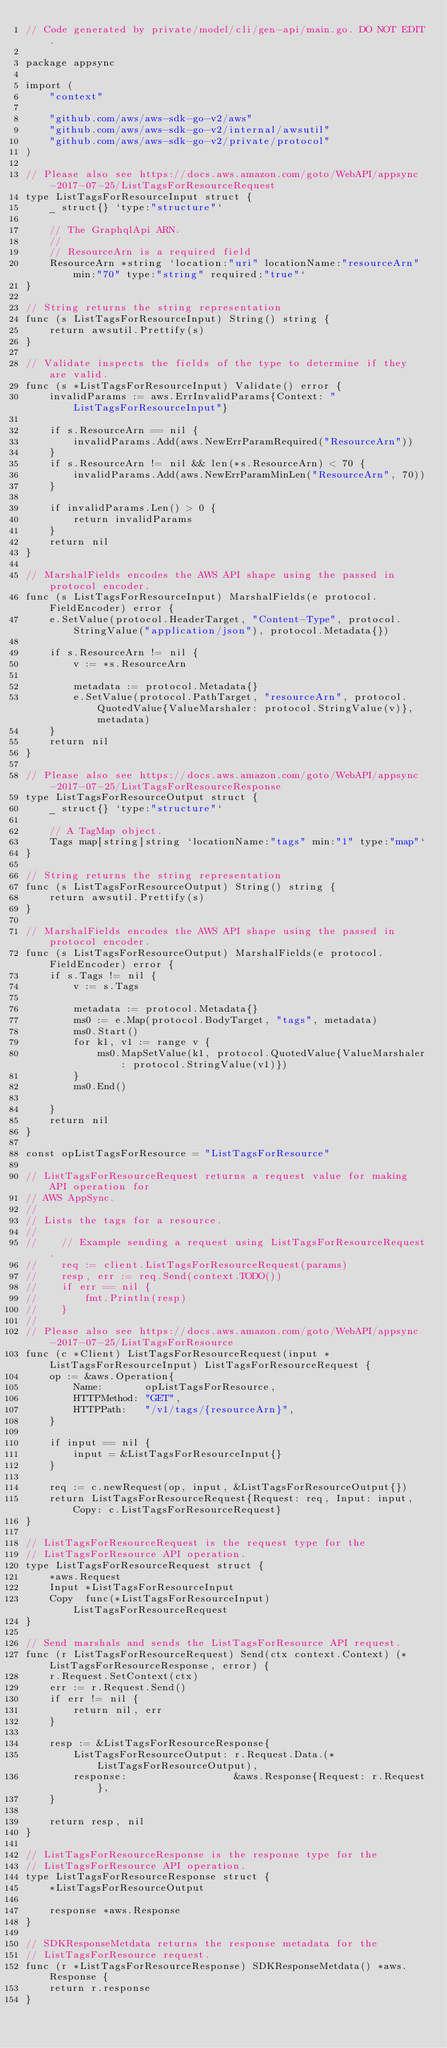Convert code to text. <code><loc_0><loc_0><loc_500><loc_500><_Go_>// Code generated by private/model/cli/gen-api/main.go. DO NOT EDIT.

package appsync

import (
	"context"

	"github.com/aws/aws-sdk-go-v2/aws"
	"github.com/aws/aws-sdk-go-v2/internal/awsutil"
	"github.com/aws/aws-sdk-go-v2/private/protocol"
)

// Please also see https://docs.aws.amazon.com/goto/WebAPI/appsync-2017-07-25/ListTagsForResourceRequest
type ListTagsForResourceInput struct {
	_ struct{} `type:"structure"`

	// The GraphqlApi ARN.
	//
	// ResourceArn is a required field
	ResourceArn *string `location:"uri" locationName:"resourceArn" min:"70" type:"string" required:"true"`
}

// String returns the string representation
func (s ListTagsForResourceInput) String() string {
	return awsutil.Prettify(s)
}

// Validate inspects the fields of the type to determine if they are valid.
func (s *ListTagsForResourceInput) Validate() error {
	invalidParams := aws.ErrInvalidParams{Context: "ListTagsForResourceInput"}

	if s.ResourceArn == nil {
		invalidParams.Add(aws.NewErrParamRequired("ResourceArn"))
	}
	if s.ResourceArn != nil && len(*s.ResourceArn) < 70 {
		invalidParams.Add(aws.NewErrParamMinLen("ResourceArn", 70))
	}

	if invalidParams.Len() > 0 {
		return invalidParams
	}
	return nil
}

// MarshalFields encodes the AWS API shape using the passed in protocol encoder.
func (s ListTagsForResourceInput) MarshalFields(e protocol.FieldEncoder) error {
	e.SetValue(protocol.HeaderTarget, "Content-Type", protocol.StringValue("application/json"), protocol.Metadata{})

	if s.ResourceArn != nil {
		v := *s.ResourceArn

		metadata := protocol.Metadata{}
		e.SetValue(protocol.PathTarget, "resourceArn", protocol.QuotedValue{ValueMarshaler: protocol.StringValue(v)}, metadata)
	}
	return nil
}

// Please also see https://docs.aws.amazon.com/goto/WebAPI/appsync-2017-07-25/ListTagsForResourceResponse
type ListTagsForResourceOutput struct {
	_ struct{} `type:"structure"`

	// A TagMap object.
	Tags map[string]string `locationName:"tags" min:"1" type:"map"`
}

// String returns the string representation
func (s ListTagsForResourceOutput) String() string {
	return awsutil.Prettify(s)
}

// MarshalFields encodes the AWS API shape using the passed in protocol encoder.
func (s ListTagsForResourceOutput) MarshalFields(e protocol.FieldEncoder) error {
	if s.Tags != nil {
		v := s.Tags

		metadata := protocol.Metadata{}
		ms0 := e.Map(protocol.BodyTarget, "tags", metadata)
		ms0.Start()
		for k1, v1 := range v {
			ms0.MapSetValue(k1, protocol.QuotedValue{ValueMarshaler: protocol.StringValue(v1)})
		}
		ms0.End()

	}
	return nil
}

const opListTagsForResource = "ListTagsForResource"

// ListTagsForResourceRequest returns a request value for making API operation for
// AWS AppSync.
//
// Lists the tags for a resource.
//
//    // Example sending a request using ListTagsForResourceRequest.
//    req := client.ListTagsForResourceRequest(params)
//    resp, err := req.Send(context.TODO())
//    if err == nil {
//        fmt.Println(resp)
//    }
//
// Please also see https://docs.aws.amazon.com/goto/WebAPI/appsync-2017-07-25/ListTagsForResource
func (c *Client) ListTagsForResourceRequest(input *ListTagsForResourceInput) ListTagsForResourceRequest {
	op := &aws.Operation{
		Name:       opListTagsForResource,
		HTTPMethod: "GET",
		HTTPPath:   "/v1/tags/{resourceArn}",
	}

	if input == nil {
		input = &ListTagsForResourceInput{}
	}

	req := c.newRequest(op, input, &ListTagsForResourceOutput{})
	return ListTagsForResourceRequest{Request: req, Input: input, Copy: c.ListTagsForResourceRequest}
}

// ListTagsForResourceRequest is the request type for the
// ListTagsForResource API operation.
type ListTagsForResourceRequest struct {
	*aws.Request
	Input *ListTagsForResourceInput
	Copy  func(*ListTagsForResourceInput) ListTagsForResourceRequest
}

// Send marshals and sends the ListTagsForResource API request.
func (r ListTagsForResourceRequest) Send(ctx context.Context) (*ListTagsForResourceResponse, error) {
	r.Request.SetContext(ctx)
	err := r.Request.Send()
	if err != nil {
		return nil, err
	}

	resp := &ListTagsForResourceResponse{
		ListTagsForResourceOutput: r.Request.Data.(*ListTagsForResourceOutput),
		response:                  &aws.Response{Request: r.Request},
	}

	return resp, nil
}

// ListTagsForResourceResponse is the response type for the
// ListTagsForResource API operation.
type ListTagsForResourceResponse struct {
	*ListTagsForResourceOutput

	response *aws.Response
}

// SDKResponseMetdata returns the response metadata for the
// ListTagsForResource request.
func (r *ListTagsForResourceResponse) SDKResponseMetdata() *aws.Response {
	return r.response
}
</code> 